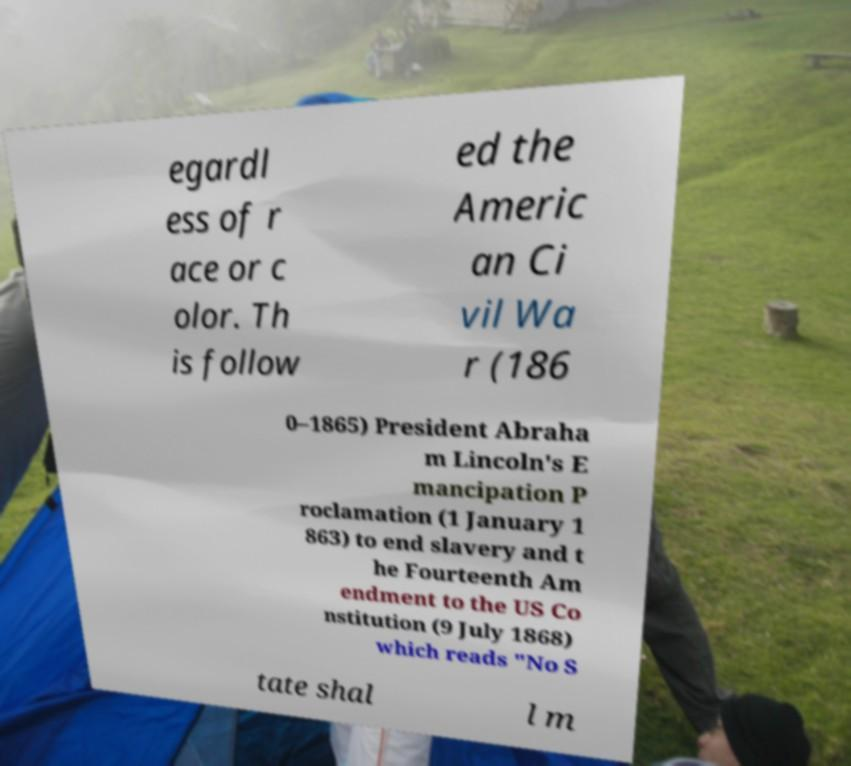Could you extract and type out the text from this image? egardl ess of r ace or c olor. Th is follow ed the Americ an Ci vil Wa r (186 0–1865) President Abraha m Lincoln's E mancipation P roclamation (1 January 1 863) to end slavery and t he Fourteenth Am endment to the US Co nstitution (9 July 1868) which reads "No S tate shal l m 